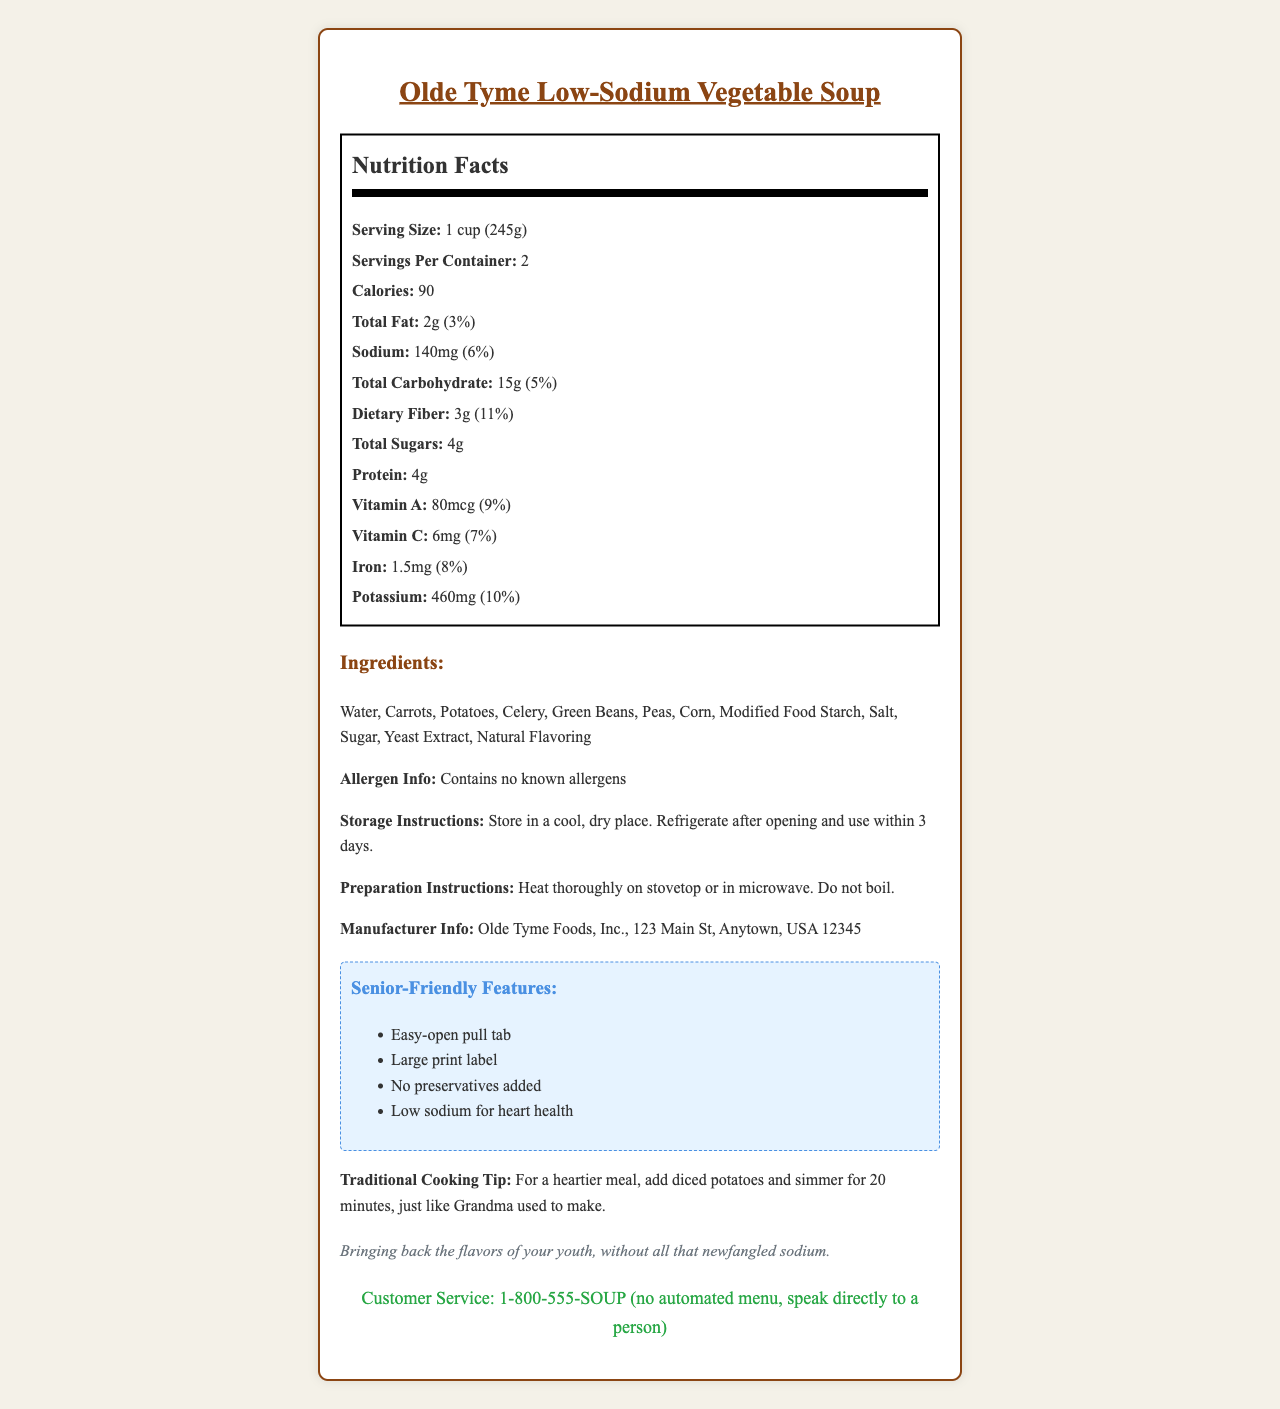what is the serving size? The document states, "Serving Size: 1 cup (245g)" under the Nutrition Facts section.
Answer: 1 cup (245g) how many servings are in the container? The document mentions, "Servings Per Container: 2" in the Nutrition Facts section.
Answer: 2 how many calories are in one serving of the soup? According to the Nutrition Facts, the calories per serving are listed as 90.
Answer: 90 how much Vitamin A does the soup contain per serving? The Nutrition Facts section specifies, "Vitamin A: 80mcg (9%)".
Answer: 80mcg how much Vitamin C does the soup contain per serving? The Nutrition Facts section indicates, "Vitamin C: 6mg (7%)".
Answer: 6mg what are the storage instructions for this soup? The storage instructions are detailed under the section "Storage Instructions."
Answer: Store in a cool, dry place. Refrigerate after opening and use within 3 days. which is the third ingredient listed? The ingredient list shows ingredients in sequence, with the third one being "Potatoes."
Answer: Potatoes which features make the soup senior-friendly? A. Low sodium for heart health B. Easy-open pull tab C. No artificial coloring D. High fiber content The document lists "Easy-open pull tab" as one of the senior-friendly features.
Answer: B how much protein is in one serving of the soup? The Nutrition Facts indicate that the protein content per serving is 4g.
Answer: 4g does the soup contain any allergens? The document mentions "Contains no known allergens" under Allergen Info.
Answer: No which company manufactures this soup? A. Olde Tyme Foods, Inc. B. Healthy Eats Corp. C. Grandma's Recipe Ltd. The document lists "Olde Tyme Foods, Inc." as the manufacturer.
Answer: A is there any sugar in the soup? The Nutrition Facts mention "Total Sugars: 4g," indicating the presence of sugar.
Answer: Yes how can one contact customer service? The document specifies, "Customer Service: 1-800-555-SOUP (no automated menu, speak directly to a person)."
Answer: 1-800-555-SOUP how much sodium is in one serving of the soup? The Nutrition Facts state, "Sodium: 140mg (6%)."
Answer: 140mg summarize the main features of this soup. The document provides comprehensive details about the product's nutrition, ingredients, and special features aimed at making it senior-friendly. It also includes practical information on storage, preparation, and customer service contact.
Answer: Olde Tyme Low-Sodium Vegetable Soup provides a blend of various vegetables with low sodium content, offering several senior-friendly features such as an easy-open pull tab and large print label. It contains 90 calories per serving and notable amounts of Vitamin A (80mcg) and Vitamin C (6mg). The product includes no known allergens and has storage and preparation guidelines for convenience. how many different vegetables are listed in the ingredients? The ingredients list mentions several vegetables, but the exact number isn't specified distinctly. The vegetables are mixed with other non-vegetable ingredients in the list.
Answer: Cannot be determined 